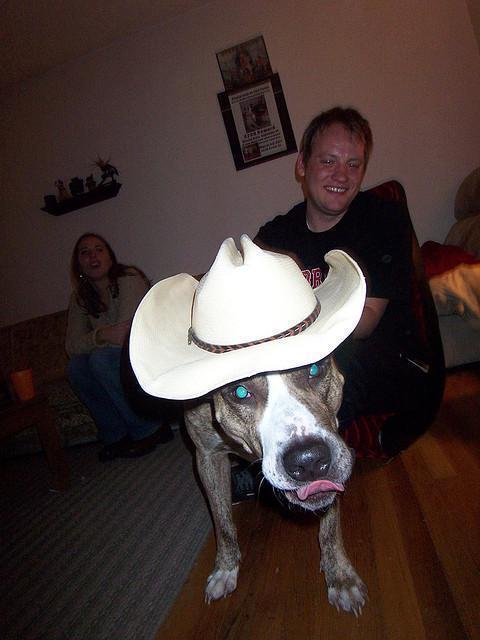Who put the hat on the dog?
Select the accurate answer and provide justification: `Answer: choice
Rationale: srationale.`
Options: Woman, cat, dog, man behind. Answer: man behind.
Rationale: There is a man behind the dog that is probably the owner that put the hat on him. 